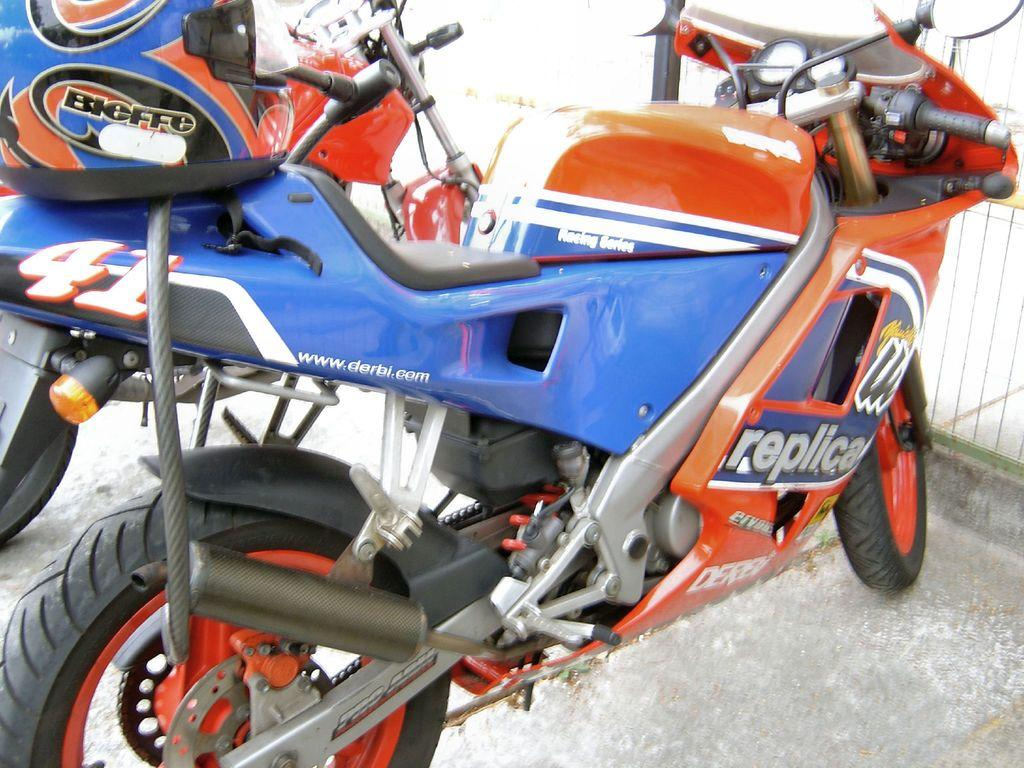What vehicles are present in the image? There are two motorcycles in the image. What protective gear is visible in the image? There is a blue color helmet in the image. Are there any words or text present in the image? Yes, there is writing present at a few places in the image. Can you see a cactus growing near the motorcycles in the image? No, there is no cactus present in the image. Is there a farmer standing next to the motorcycles in the image? No, there is no farmer present in the image. 